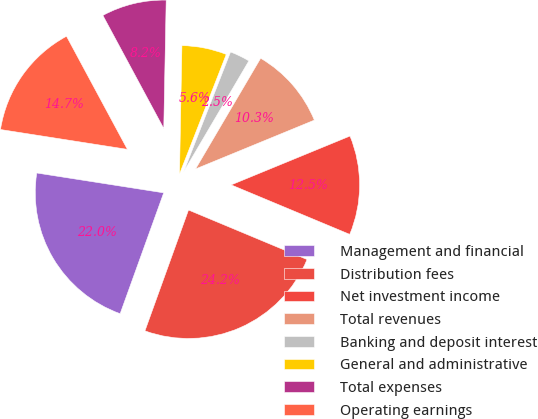Convert chart. <chart><loc_0><loc_0><loc_500><loc_500><pie_chart><fcel>Management and financial<fcel>Distribution fees<fcel>Net investment income<fcel>Total revenues<fcel>Banking and deposit interest<fcel>General and administrative<fcel>Total expenses<fcel>Operating earnings<nl><fcel>21.96%<fcel>24.21%<fcel>12.5%<fcel>10.33%<fcel>2.53%<fcel>5.63%<fcel>8.16%<fcel>14.67%<nl></chart> 